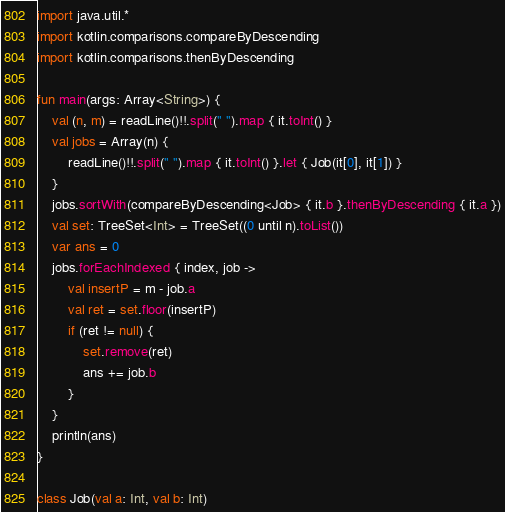Convert code to text. <code><loc_0><loc_0><loc_500><loc_500><_Kotlin_>import java.util.*
import kotlin.comparisons.compareByDescending
import kotlin.comparisons.thenByDescending

fun main(args: Array<String>) {
    val (n, m) = readLine()!!.split(" ").map { it.toInt() }
    val jobs = Array(n) {
        readLine()!!.split(" ").map { it.toInt() }.let { Job(it[0], it[1]) }
    }
    jobs.sortWith(compareByDescending<Job> { it.b }.thenByDescending { it.a })
    val set: TreeSet<Int> = TreeSet((0 until n).toList())
    var ans = 0
    jobs.forEachIndexed { index, job ->
        val insertP = m - job.a
        val ret = set.floor(insertP)
        if (ret != null) {
            set.remove(ret)
            ans += job.b
        }
    }
    println(ans)
}

class Job(val a: Int, val b: Int)</code> 